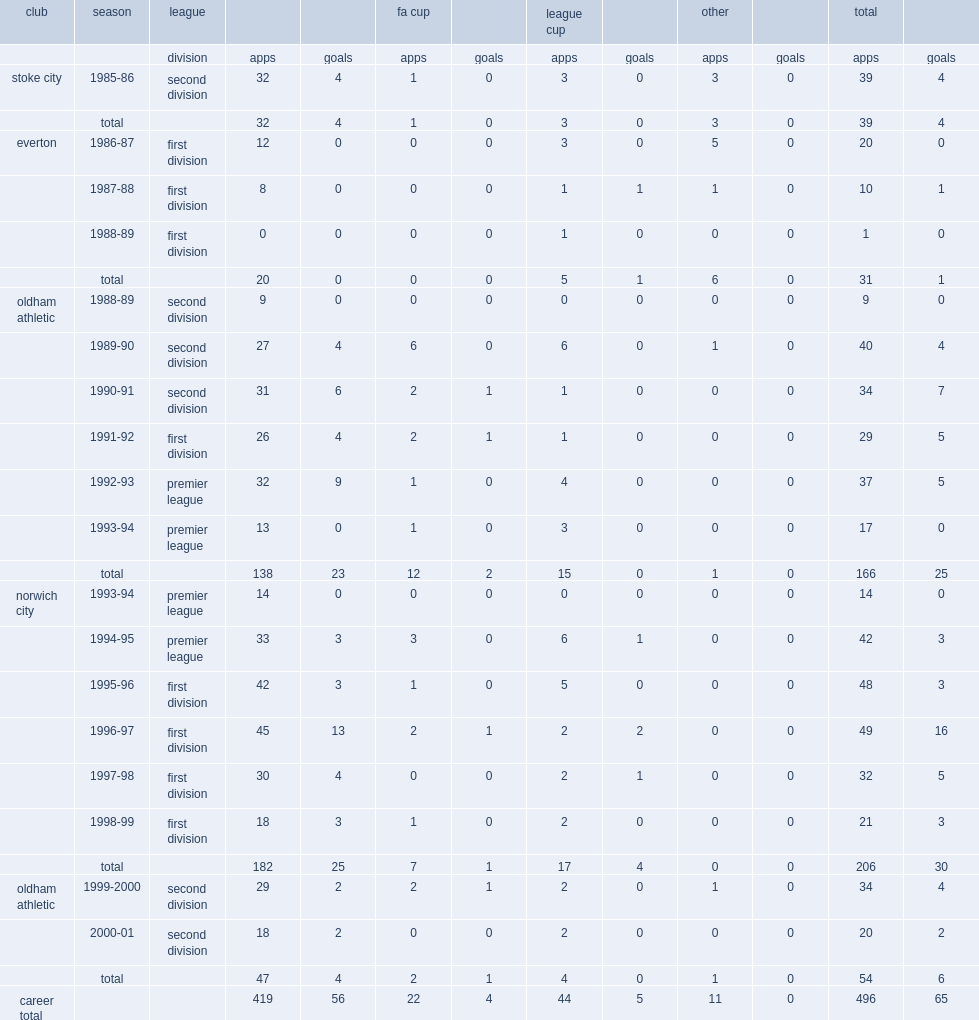Which club did neil adams join in first division in 1986-87? Everton. 